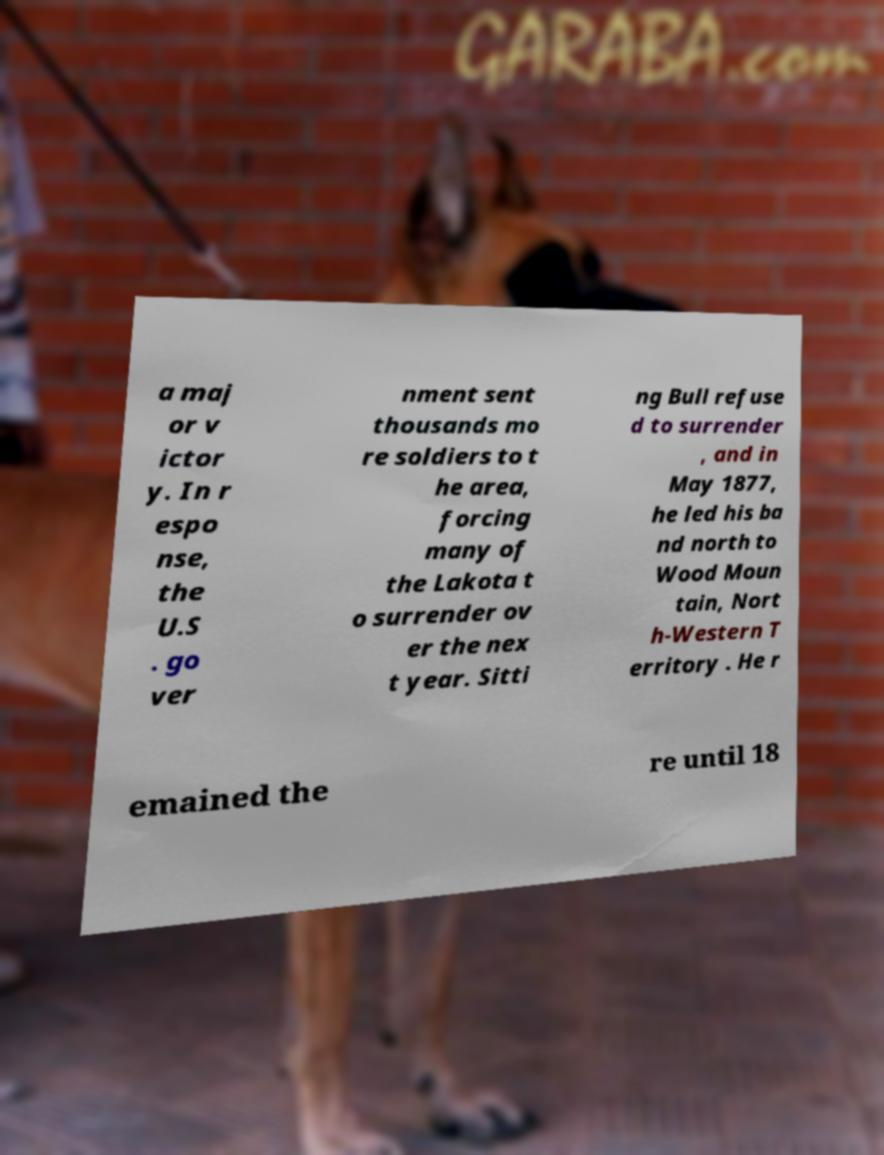What messages or text are displayed in this image? I need them in a readable, typed format. a maj or v ictor y. In r espo nse, the U.S . go ver nment sent thousands mo re soldiers to t he area, forcing many of the Lakota t o surrender ov er the nex t year. Sitti ng Bull refuse d to surrender , and in May 1877, he led his ba nd north to Wood Moun tain, Nort h-Western T erritory . He r emained the re until 18 